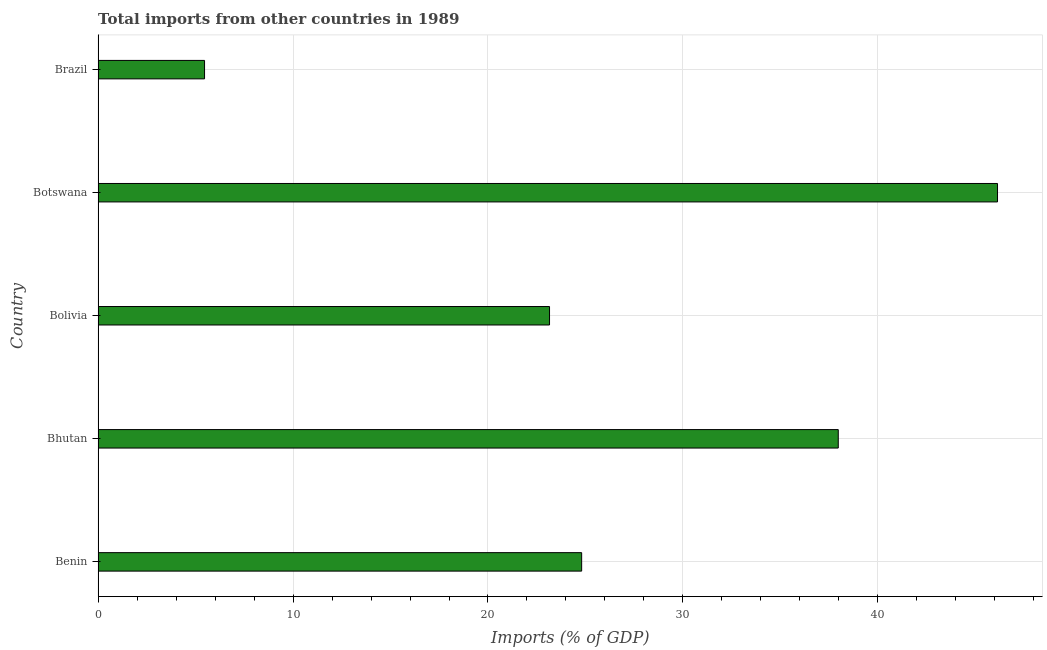What is the title of the graph?
Provide a succinct answer. Total imports from other countries in 1989. What is the label or title of the X-axis?
Make the answer very short. Imports (% of GDP). What is the total imports in Botswana?
Provide a succinct answer. 46.14. Across all countries, what is the maximum total imports?
Make the answer very short. 46.14. Across all countries, what is the minimum total imports?
Your answer should be compact. 5.46. In which country was the total imports maximum?
Your answer should be very brief. Botswana. In which country was the total imports minimum?
Offer a terse response. Brazil. What is the sum of the total imports?
Make the answer very short. 137.53. What is the difference between the total imports in Benin and Botswana?
Offer a terse response. -21.33. What is the average total imports per country?
Your response must be concise. 27.5. What is the median total imports?
Offer a very short reply. 24.8. In how many countries, is the total imports greater than 36 %?
Make the answer very short. 2. What is the ratio of the total imports in Bhutan to that in Bolivia?
Give a very brief answer. 1.64. Is the difference between the total imports in Bolivia and Brazil greater than the difference between any two countries?
Make the answer very short. No. What is the difference between the highest and the second highest total imports?
Make the answer very short. 8.17. Is the sum of the total imports in Bhutan and Botswana greater than the maximum total imports across all countries?
Offer a terse response. Yes. What is the difference between the highest and the lowest total imports?
Ensure brevity in your answer.  40.67. In how many countries, is the total imports greater than the average total imports taken over all countries?
Provide a succinct answer. 2. How many countries are there in the graph?
Offer a terse response. 5. What is the difference between two consecutive major ticks on the X-axis?
Offer a terse response. 10. What is the Imports (% of GDP) of Benin?
Give a very brief answer. 24.8. What is the Imports (% of GDP) of Bhutan?
Your answer should be compact. 37.97. What is the Imports (% of GDP) in Bolivia?
Your answer should be very brief. 23.16. What is the Imports (% of GDP) of Botswana?
Offer a very short reply. 46.14. What is the Imports (% of GDP) in Brazil?
Keep it short and to the point. 5.46. What is the difference between the Imports (% of GDP) in Benin and Bhutan?
Make the answer very short. -13.16. What is the difference between the Imports (% of GDP) in Benin and Bolivia?
Keep it short and to the point. 1.65. What is the difference between the Imports (% of GDP) in Benin and Botswana?
Give a very brief answer. -21.33. What is the difference between the Imports (% of GDP) in Benin and Brazil?
Your answer should be very brief. 19.34. What is the difference between the Imports (% of GDP) in Bhutan and Bolivia?
Give a very brief answer. 14.81. What is the difference between the Imports (% of GDP) in Bhutan and Botswana?
Your response must be concise. -8.17. What is the difference between the Imports (% of GDP) in Bhutan and Brazil?
Make the answer very short. 32.51. What is the difference between the Imports (% of GDP) in Bolivia and Botswana?
Ensure brevity in your answer.  -22.98. What is the difference between the Imports (% of GDP) in Bolivia and Brazil?
Your answer should be very brief. 17.7. What is the difference between the Imports (% of GDP) in Botswana and Brazil?
Give a very brief answer. 40.67. What is the ratio of the Imports (% of GDP) in Benin to that in Bhutan?
Offer a terse response. 0.65. What is the ratio of the Imports (% of GDP) in Benin to that in Bolivia?
Your response must be concise. 1.07. What is the ratio of the Imports (% of GDP) in Benin to that in Botswana?
Your answer should be very brief. 0.54. What is the ratio of the Imports (% of GDP) in Benin to that in Brazil?
Offer a very short reply. 4.54. What is the ratio of the Imports (% of GDP) in Bhutan to that in Bolivia?
Provide a succinct answer. 1.64. What is the ratio of the Imports (% of GDP) in Bhutan to that in Botswana?
Offer a terse response. 0.82. What is the ratio of the Imports (% of GDP) in Bhutan to that in Brazil?
Ensure brevity in your answer.  6.95. What is the ratio of the Imports (% of GDP) in Bolivia to that in Botswana?
Your response must be concise. 0.5. What is the ratio of the Imports (% of GDP) in Bolivia to that in Brazil?
Ensure brevity in your answer.  4.24. What is the ratio of the Imports (% of GDP) in Botswana to that in Brazil?
Offer a very short reply. 8.45. 